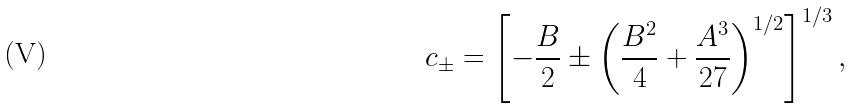Convert formula to latex. <formula><loc_0><loc_0><loc_500><loc_500>c _ { \pm } = \left [ - \frac { B } { 2 } \pm \left ( \frac { B ^ { 2 } } 4 + \frac { A ^ { 3 } } { 2 7 } \right ) ^ { 1 / 2 } \right ] ^ { 1 / 3 } ,</formula> 